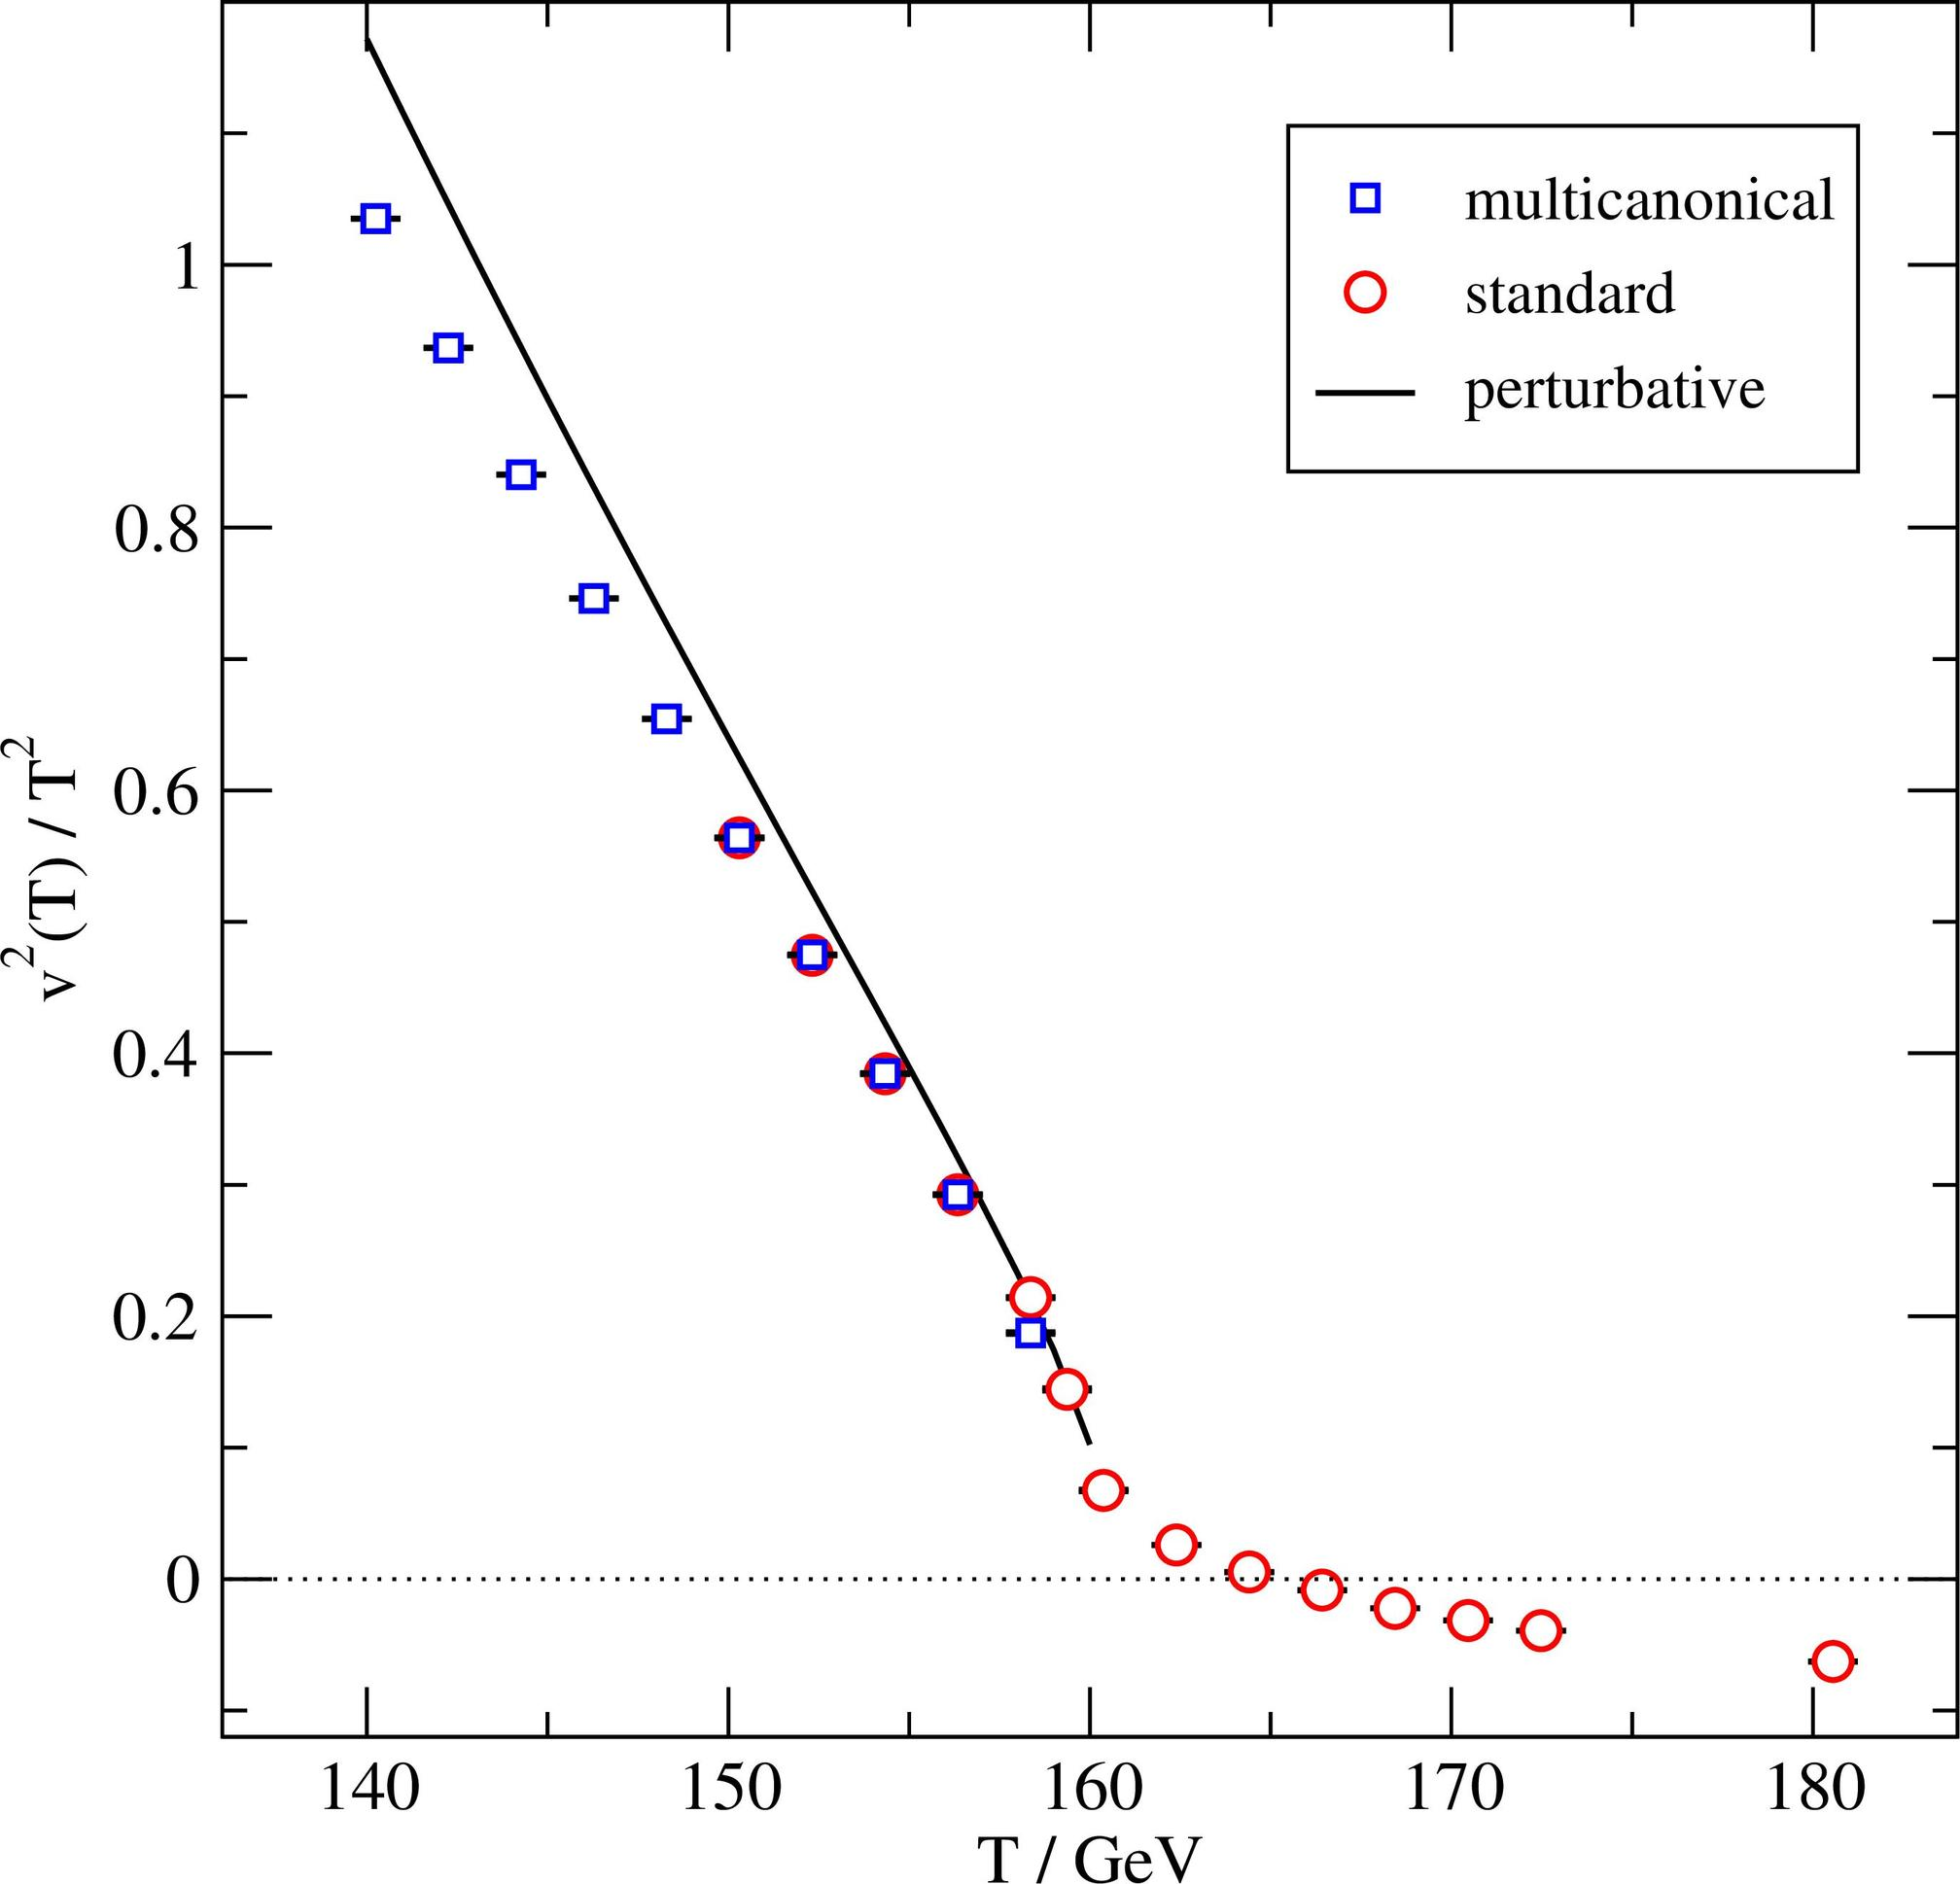Can you explain why the discrepancy in measurements might be particularly high in the 160-170 GeV range? The pronounced discrepancy between the multicanonical and standard measurements in the 160-170 GeV range could be due to various reasons. One possibility might be the inherent instability in particle interactions at this energy level, which makes it challenging to capture with standard experimental techniques. Another reason could be differences in calibration or measurement sensitivity inherent to the two methodologies. Such variations are critical for theoretical physicists because they provide insights into where and why different techniques might vary and how to adjust theoretical models or experimental conditions to align them. 